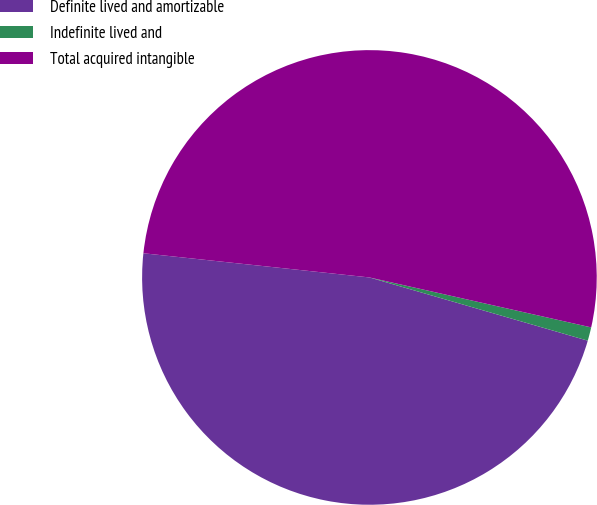Convert chart to OTSL. <chart><loc_0><loc_0><loc_500><loc_500><pie_chart><fcel>Definite lived and amortizable<fcel>Indefinite lived and<fcel>Total acquired intangible<nl><fcel>47.21%<fcel>0.96%<fcel>51.83%<nl></chart> 